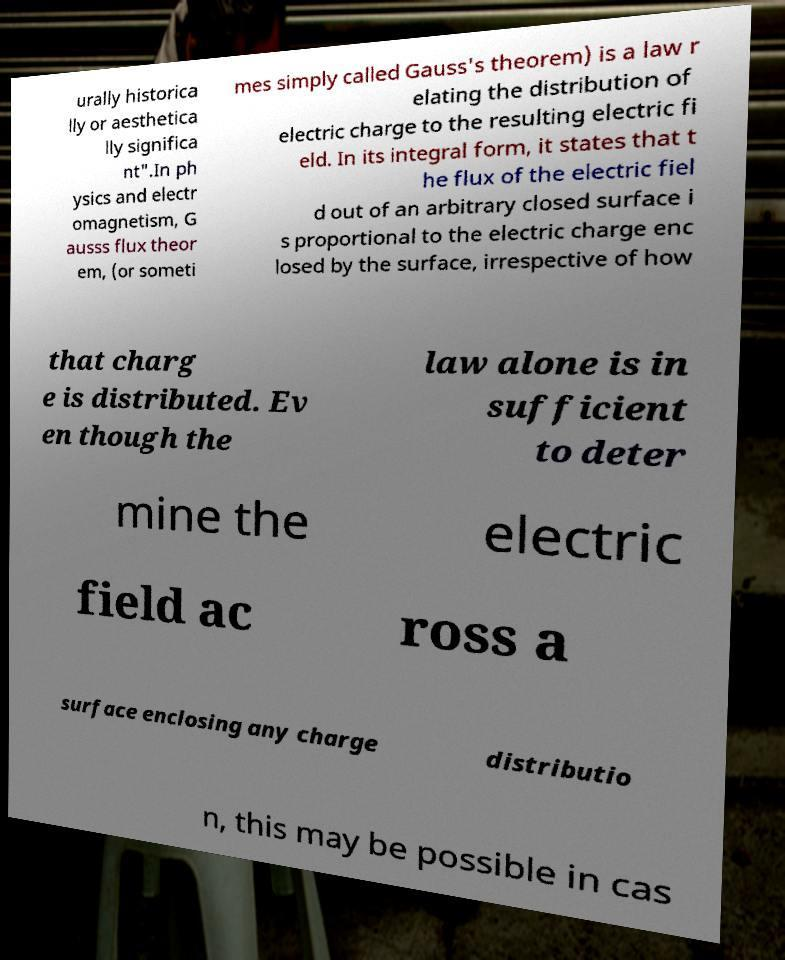Can you read and provide the text displayed in the image?This photo seems to have some interesting text. Can you extract and type it out for me? urally historica lly or aesthetica lly significa nt".In ph ysics and electr omagnetism, G ausss flux theor em, (or someti mes simply called Gauss's theorem) is a law r elating the distribution of electric charge to the resulting electric fi eld. In its integral form, it states that t he flux of the electric fiel d out of an arbitrary closed surface i s proportional to the electric charge enc losed by the surface, irrespective of how that charg e is distributed. Ev en though the law alone is in sufficient to deter mine the electric field ac ross a surface enclosing any charge distributio n, this may be possible in cas 